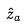Convert formula to latex. <formula><loc_0><loc_0><loc_500><loc_500>\hat { z } _ { a }</formula> 